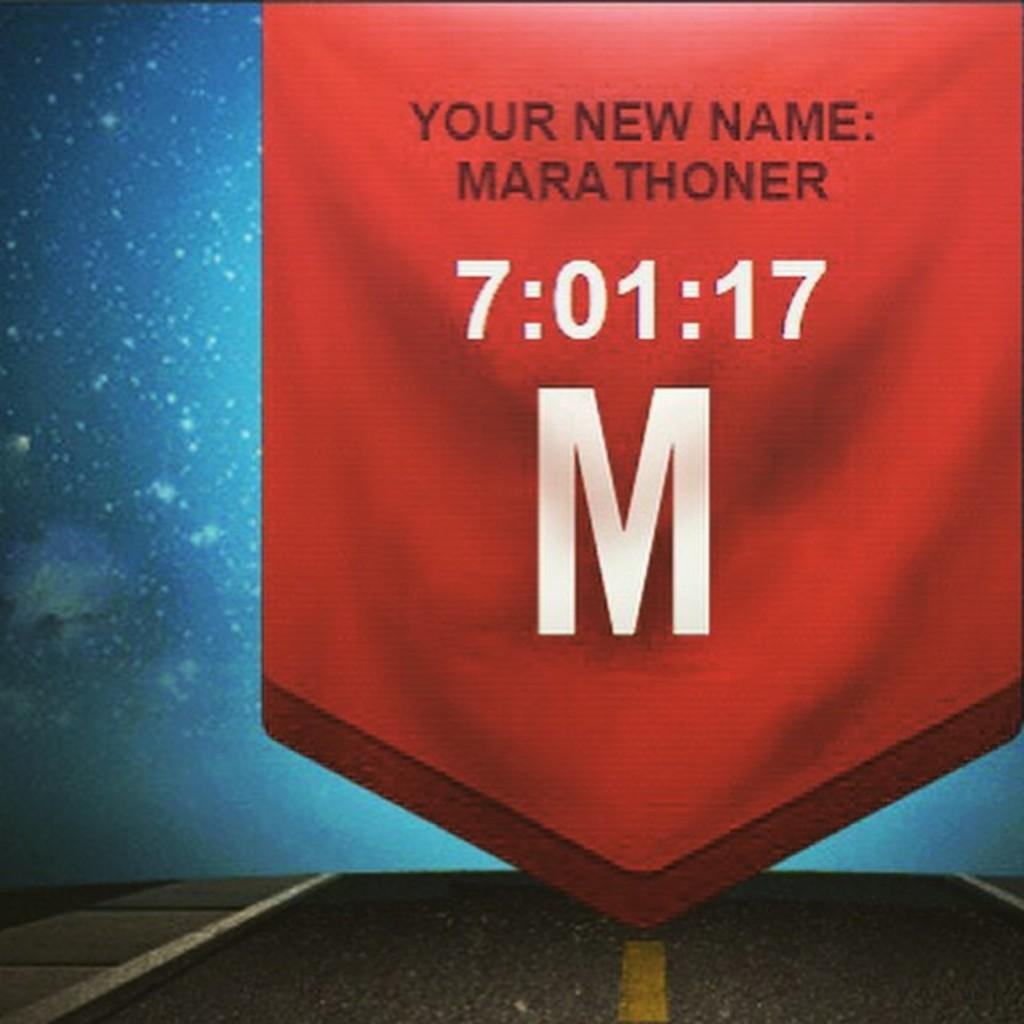<image>
Share a concise interpretation of the image provided. A red banner that says "Your new name: Marathoner,  7:01:1, M" Is displayed. 